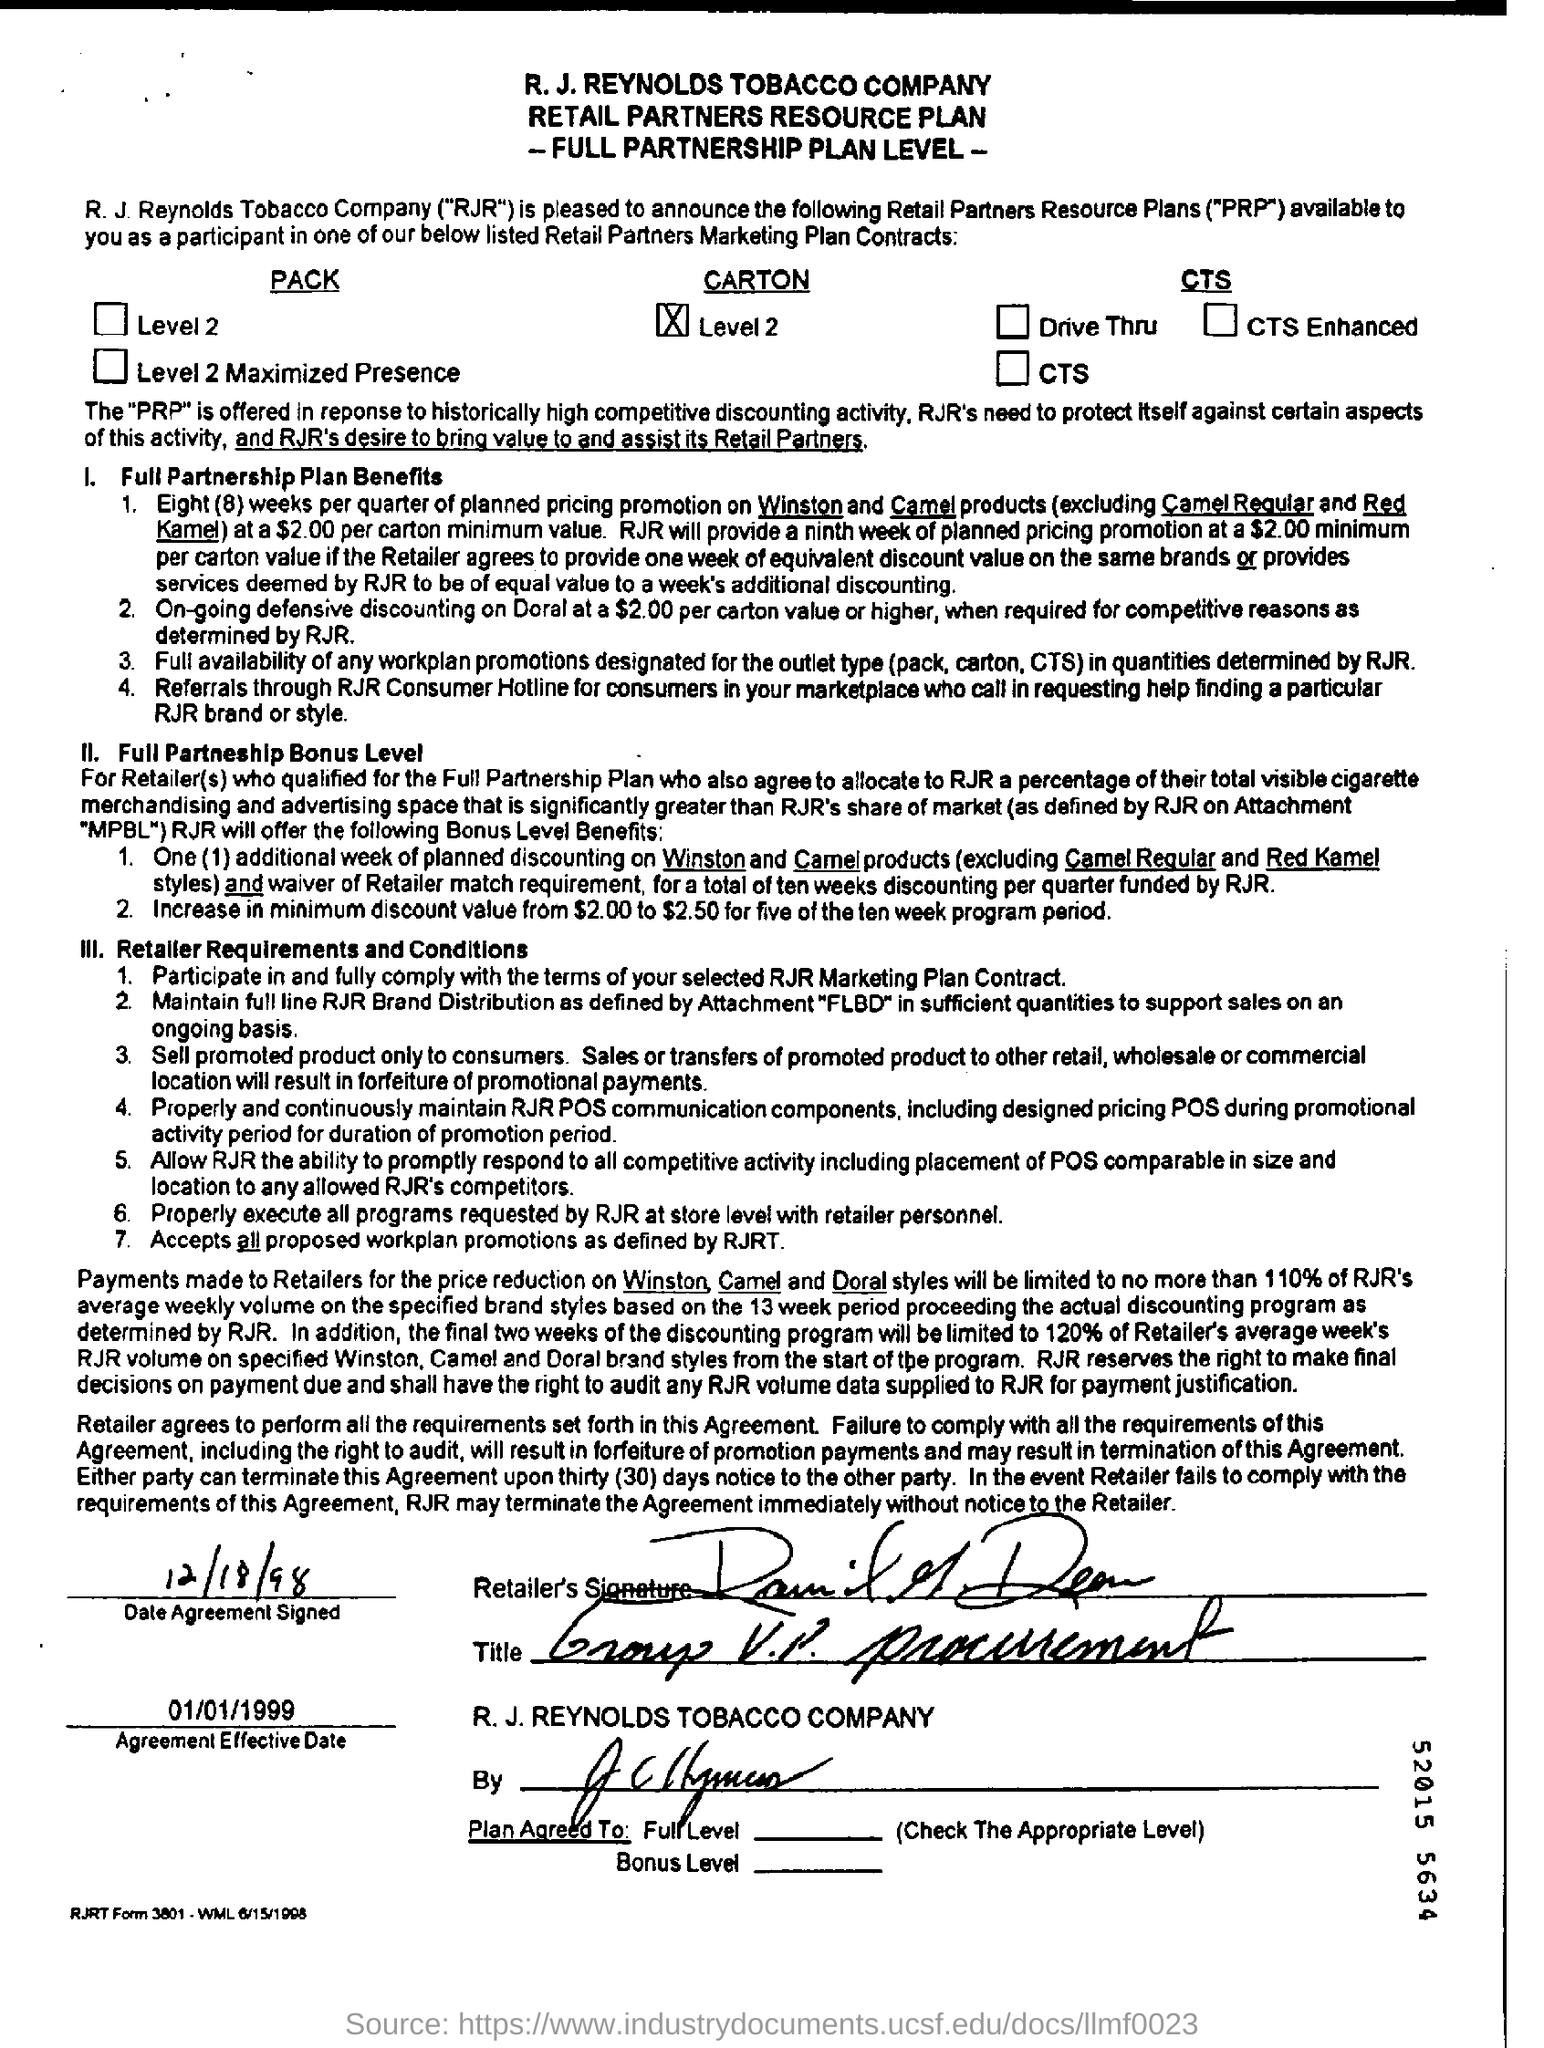When does the agreement signed?
Your answer should be compact. 12/18/98. What is the agreement effective date?
Provide a short and direct response. 01/01/1999. 